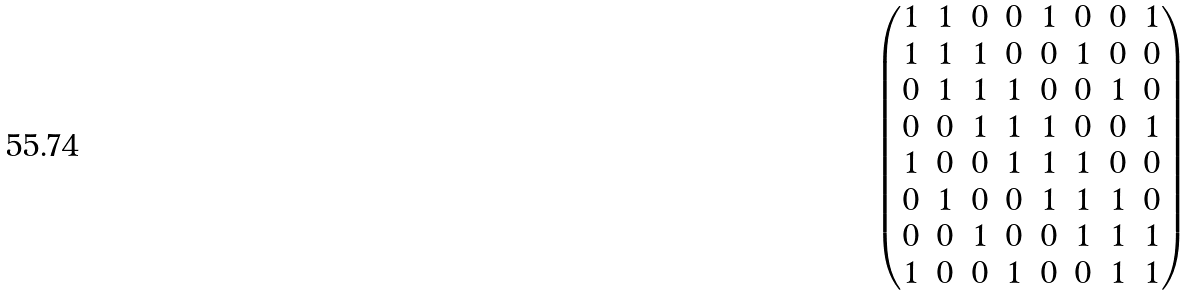Convert formula to latex. <formula><loc_0><loc_0><loc_500><loc_500>\begin{pmatrix} 1 & 1 & 0 & 0 & 1 & 0 & 0 & 1 \\ 1 & 1 & 1 & 0 & 0 & 1 & 0 & 0 \\ 0 & 1 & 1 & 1 & 0 & 0 & 1 & 0 \\ 0 & 0 & 1 & 1 & 1 & 0 & 0 & 1 \\ 1 & 0 & 0 & 1 & 1 & 1 & 0 & 0 \\ 0 & 1 & 0 & 0 & 1 & 1 & 1 & 0 \\ 0 & 0 & 1 & 0 & 0 & 1 & 1 & 1 \\ 1 & 0 & 0 & 1 & 0 & 0 & 1 & 1 \end{pmatrix}</formula> 